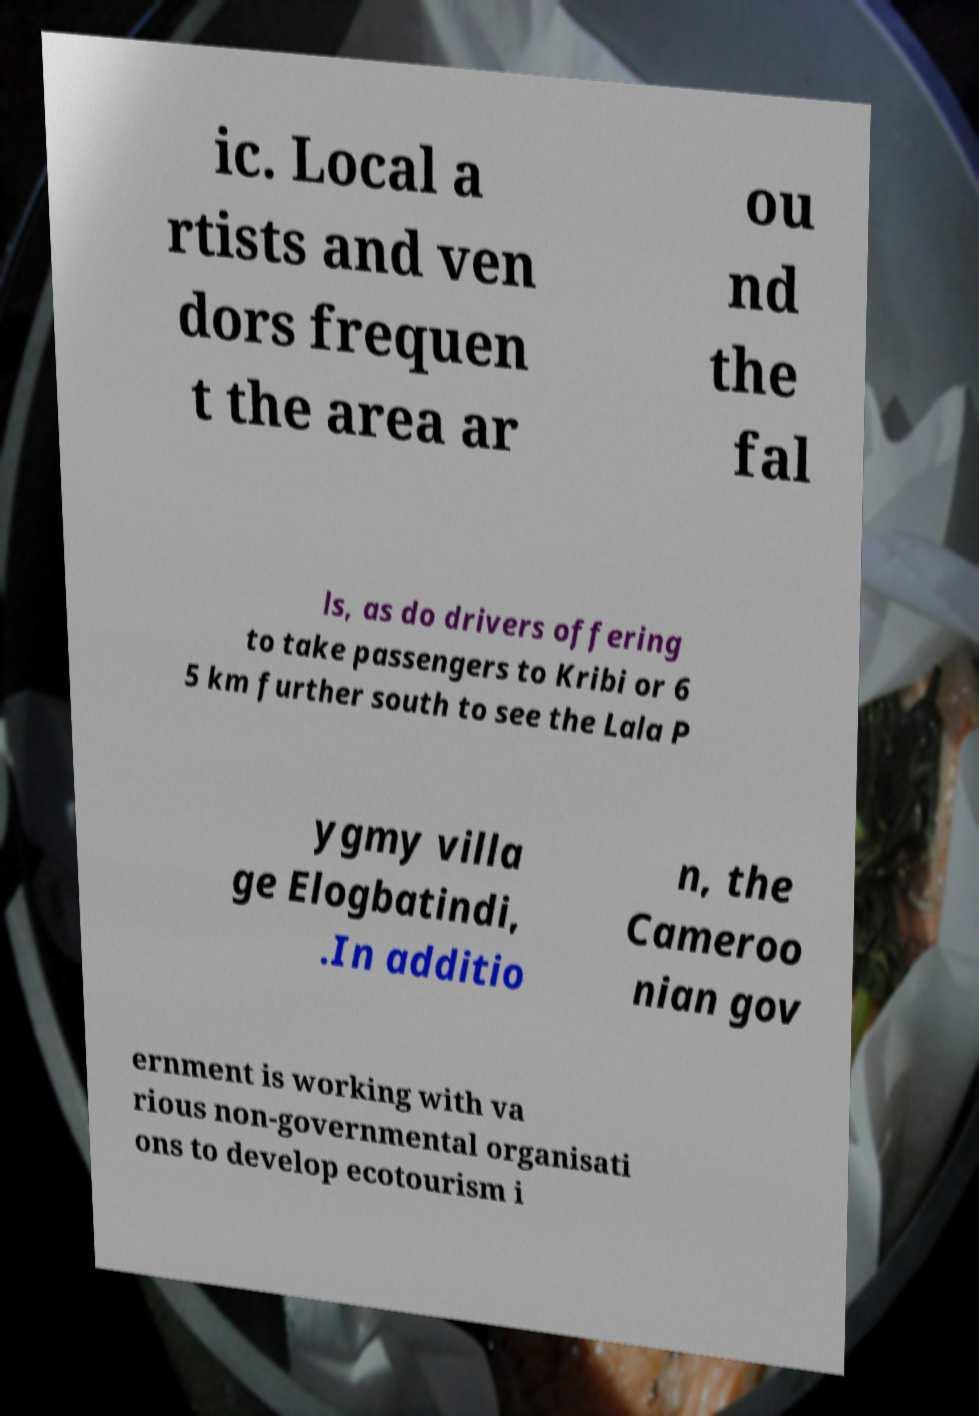What messages or text are displayed in this image? I need them in a readable, typed format. ic. Local a rtists and ven dors frequen t the area ar ou nd the fal ls, as do drivers offering to take passengers to Kribi or 6 5 km further south to see the Lala P ygmy villa ge Elogbatindi, .In additio n, the Cameroo nian gov ernment is working with va rious non-governmental organisati ons to develop ecotourism i 